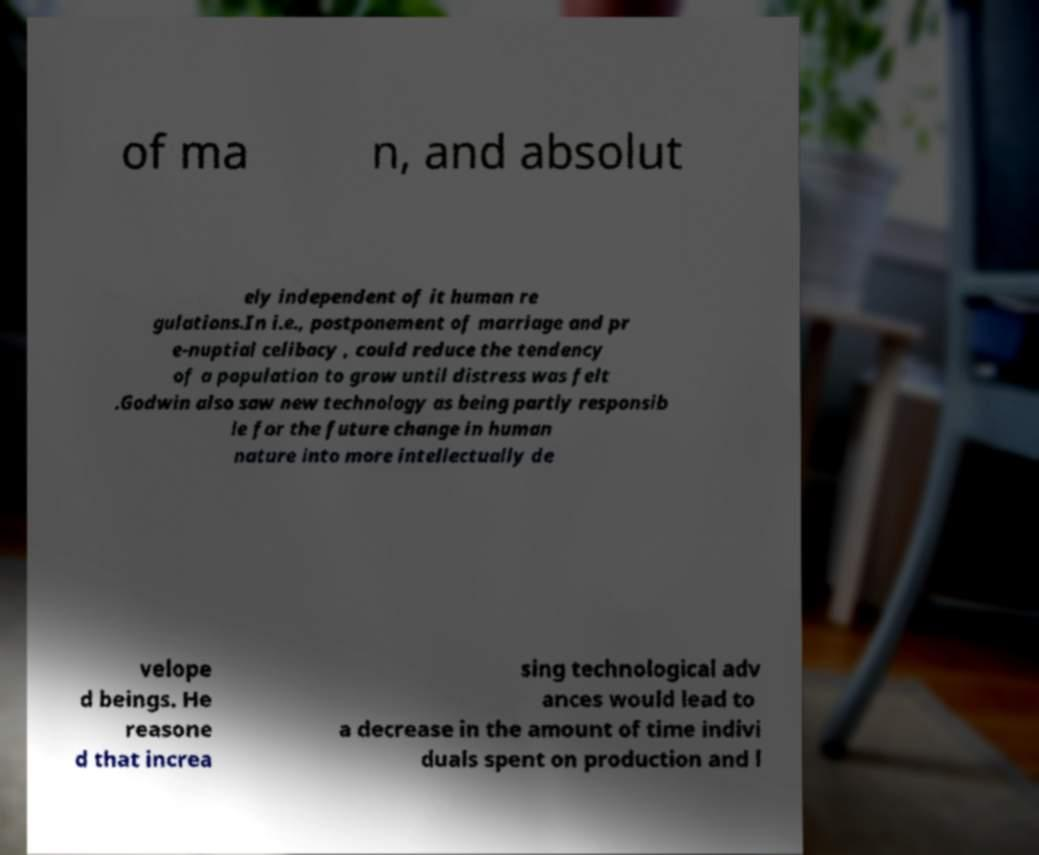Please read and relay the text visible in this image. What does it say? of ma n, and absolut ely independent of it human re gulations.In i.e., postponement of marriage and pr e-nuptial celibacy , could reduce the tendency of a population to grow until distress was felt .Godwin also saw new technology as being partly responsib le for the future change in human nature into more intellectually de velope d beings. He reasone d that increa sing technological adv ances would lead to a decrease in the amount of time indivi duals spent on production and l 